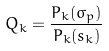<formula> <loc_0><loc_0><loc_500><loc_500>Q _ { k } = \frac { P _ { k } ( \sigma _ { p } ) } { P _ { k } ( s _ { k } ) }</formula> 